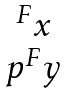Convert formula to latex. <formula><loc_0><loc_0><loc_500><loc_500>\begin{matrix} { ^ { F } x } \\ p { ^ { F } y } \end{matrix}</formula> 